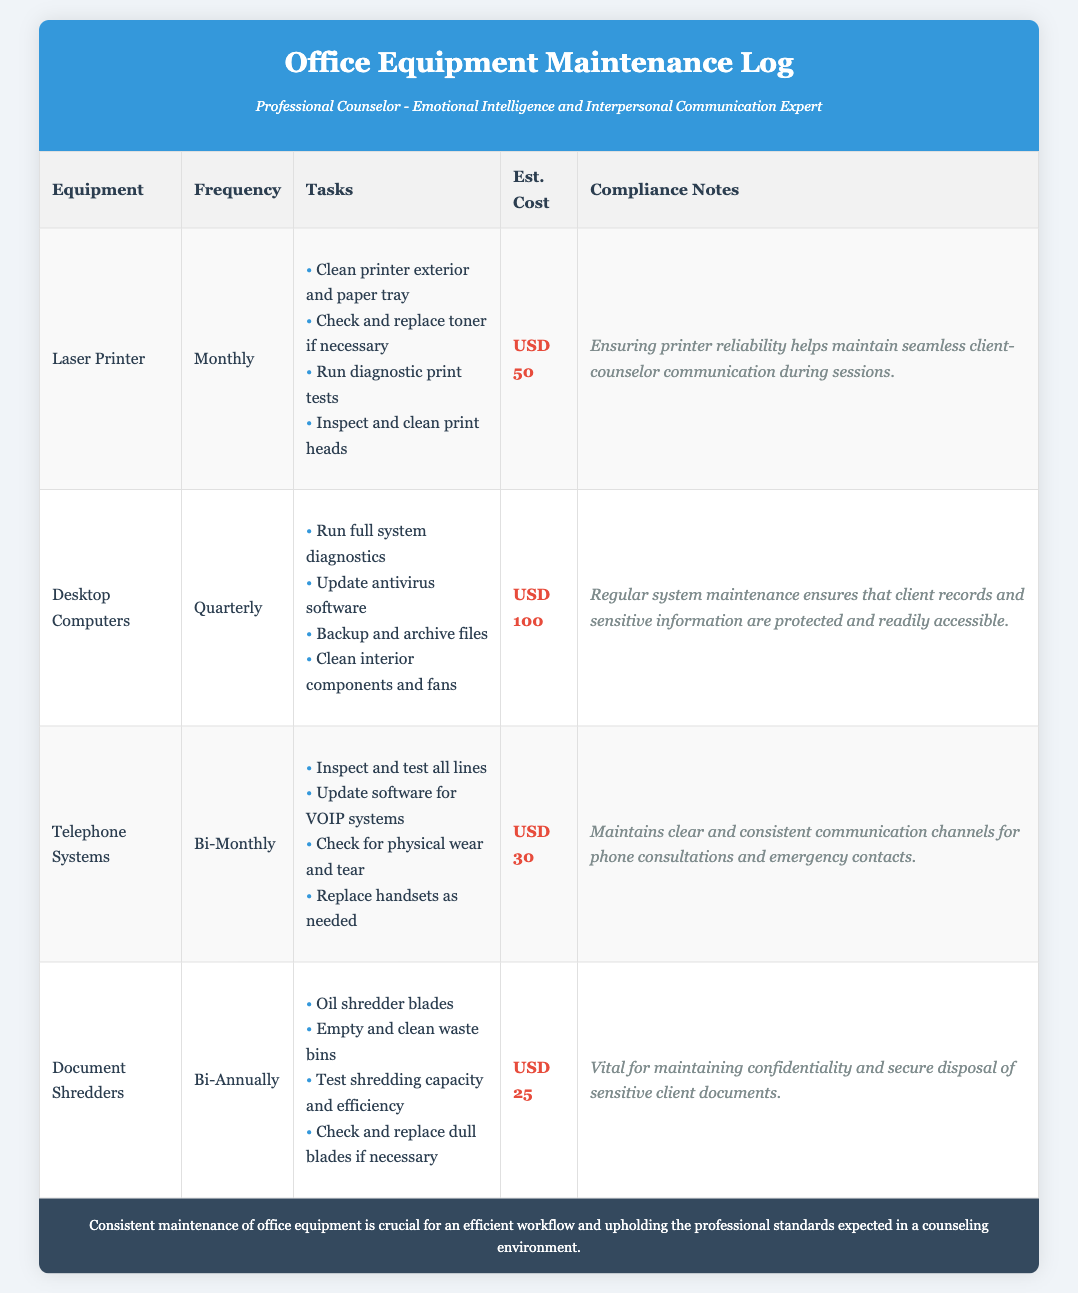What is the required maintenance frequency for the Laser Printer? The document specifies that the Laser Printer requires monthly maintenance.
Answer: Monthly What is the estimated cost for maintaining the Desktop Computers? The maintenance log lists the estimated cost for Desktop Computers maintenance as USD 100.
Answer: USD 100 How often should the Telephone Systems be maintained? According to the maintenance log, the Telephone Systems should be maintained bi-monthly.
Answer: Bi-Monthly What is one of the tasks for the Document Shredders maintenance? The tasks listed for Document Shredders maintenance include oiling shredder blades.
Answer: Oil shredder blades What is the total estimated cost for maintaining all four types of equipment? The total estimated cost is calculated as USD 50 + USD 100 + USD 30 + USD 25, which equals USD 205.
Answer: USD 205 Why is printer maintenance important according to the compliance notes? The compliance notes state that ensuring printer reliability helps maintain seamless client-counselor communication during sessions.
Answer: Seamless client-counselor communication What task is included in the maintenance schedule for Desktop Computers? One of the tasks is to update antivirus software.
Answer: Update antivirus software Which equipment requires maintenance every quarter? The Desktop Computers require maintenance every quarter.
Answer: Desktop Computers What compliance note relates to Document Shredders? The compliance note indicates that maintaining confidentiality and secure disposal of sensitive client documents is vital.
Answer: Maintaining confidentiality and secure disposal 